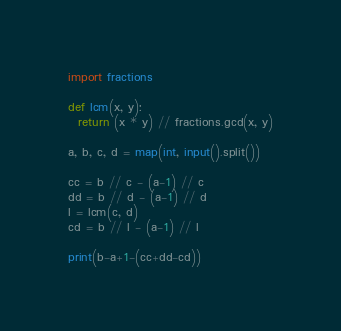<code> <loc_0><loc_0><loc_500><loc_500><_Python_>import fractions

def lcm(x, y):
  return (x * y) // fractions.gcd(x, y)

a, b, c, d = map(int, input().split())

cc = b // c - (a-1) // c
dd = b // d - (a-1) // d
l = lcm(c, d)
cd = b // l - (a-1) // l

print(b-a+1-(cc+dd-cd))
</code> 